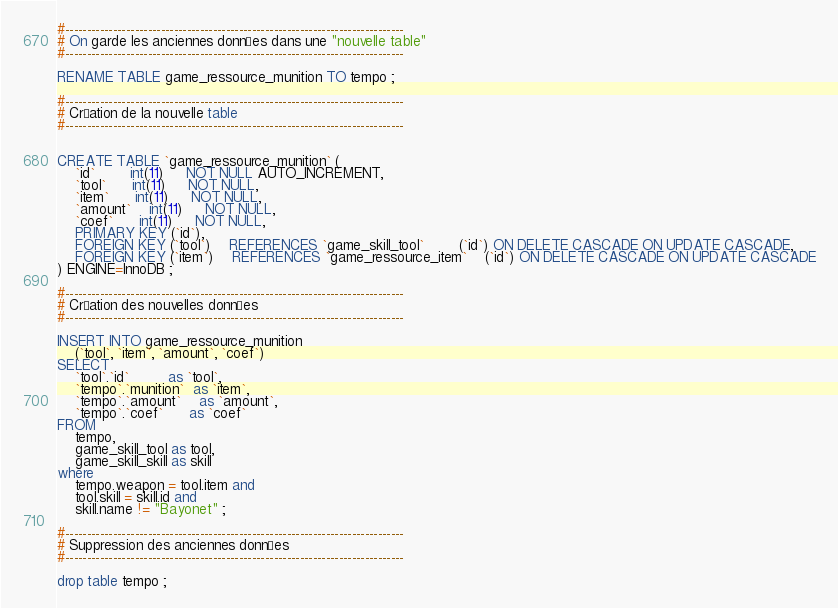Convert code to text. <code><loc_0><loc_0><loc_500><loc_500><_SQL_>
#------------------------------------------------------------------------------
# On garde les anciennes données dans une "nouvelle table"
#------------------------------------------------------------------------------

RENAME TABLE game_ressource_munition TO tempo ;

#------------------------------------------------------------------------------
# Création de la nouvelle table
#------------------------------------------------------------------------------


CREATE TABLE `game_ressource_munition` (
    `id`        int(11)     NOT NULL AUTO_INCREMENT,
    `tool`      int(11)     NOT NULL,
    `item`      int(11)     NOT NULL,
    `amount`    int(11)     NOT NULL,
    `coef`      int(11)     NOT NULL,
    PRIMARY KEY (`id`),
    FOREIGN KEY (`tool`)    REFERENCES `game_skill_tool`        (`id`) ON DELETE CASCADE ON UPDATE CASCADE,
    FOREIGN KEY (`item`)    REFERENCES `game_ressource_item`    (`id`) ON DELETE CASCADE ON UPDATE CASCADE
) ENGINE=InnoDB ;

#------------------------------------------------------------------------------
# Création des nouvelles données
#------------------------------------------------------------------------------

INSERT INTO game_ressource_munition
    (`tool`, `item`, `amount`, `coef`)
SELECT
    `tool`.`id`         as `tool`,
    `tempo`.`munition`  as `item`,
    `tempo`.`amount`    as `amount`,
    `tempo`.`coef`      as `coef`
FROM
    tempo,
    game_skill_tool as tool,
    game_skill_skill as skill
where
    tempo.weapon = tool.item and
    tool.skill = skill.id and
    skill.name != "Bayonet" ;

#------------------------------------------------------------------------------
# Suppression des anciennes données
#------------------------------------------------------------------------------

drop table tempo ;
</code> 